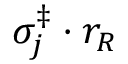Convert formula to latex. <formula><loc_0><loc_0><loc_500><loc_500>\sigma _ { j } ^ { \ddag } \cdot r _ { R }</formula> 